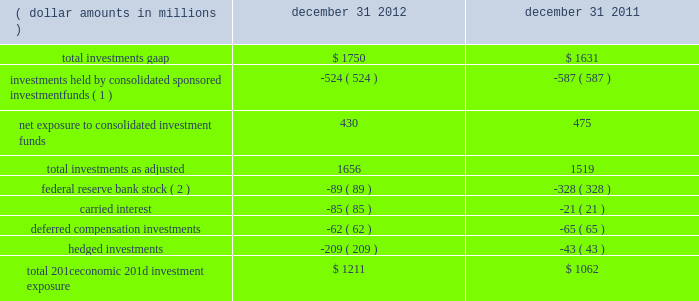The company further presents total net 201ceconomic 201d investment exposure , net of deferred compensation investments and hedged investments , to reflect another gauge for investors as the economic impact of investments held pursuant to deferred compensation arrangements is substantially offset by a change in compensation expense and the impact of hedged investments is substantially mitigated by total return swap hedges .
Carried interest capital allocations are excluded as there is no impact to blackrock 2019s stockholders 2019 equity until such amounts are realized as performance fees .
Finally , the company 2019s regulatory investment in federal reserve bank stock , which is not subject to market or interest rate risk , is excluded from the company 2019s net economic investment exposure .
( dollar amounts in millions ) december 31 , december 31 .
Total 201ceconomic 201d investment exposure .
$ 1211 $ 1062 ( 1 ) at december 31 , 2012 and december 31 , 2011 , approximately $ 524 million and $ 587 million , respectively , of blackrock 2019s total gaap investments were maintained in sponsored investment funds that were deemed to be controlled by blackrock in accordance with gaap , and , therefore , are consolidated even though blackrock may not economically own a majority of such funds .
( 2 ) the decrease of $ 239 million related to a lower holding requirement of federal reserve bank stock held by blackrock institutional trust company , n.a .
( 201cbtc 201d ) .
Total investments , as adjusted , at december 31 , 2012 increased $ 137 million from december 31 , 2011 , resulting from $ 765 million of purchases/capital contributions , $ 185 million from positive market valuations and earnings from equity method investments , and $ 64 million from net additional carried interest capital allocations , partially offset by $ 742 million of sales/maturities and $ 135 million of distributions representing return of capital and return on investments. .
What is the percentage change in the balance of total 201ceconomic 201d investment exposure from 2011 to 2012? 
Computations: ((1211 - 1062) / 1062)
Answer: 0.1403. 